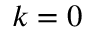<formula> <loc_0><loc_0><loc_500><loc_500>k = 0</formula> 